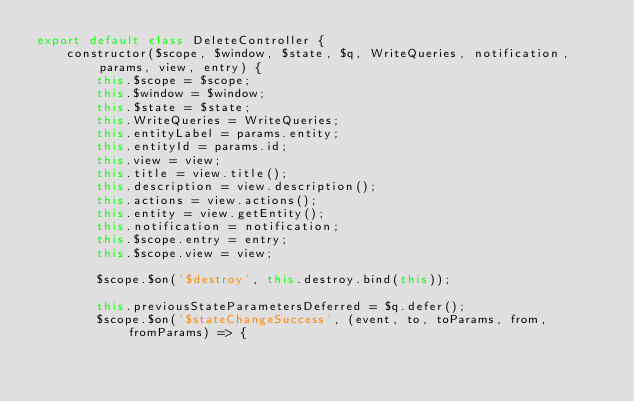<code> <loc_0><loc_0><loc_500><loc_500><_JavaScript_>export default class DeleteController {
    constructor($scope, $window, $state, $q, WriteQueries, notification, params, view, entry) {
        this.$scope = $scope;
        this.$window = $window;
        this.$state = $state;
        this.WriteQueries = WriteQueries;
        this.entityLabel = params.entity;
        this.entityId = params.id;
        this.view = view;
        this.title = view.title();
        this.description = view.description();
        this.actions = view.actions();
        this.entity = view.getEntity();
        this.notification = notification;
        this.$scope.entry = entry;
        this.$scope.view = view;

        $scope.$on('$destroy', this.destroy.bind(this));

        this.previousStateParametersDeferred = $q.defer();
        $scope.$on('$stateChangeSuccess', (event, to, toParams, from, fromParams) => {</code> 